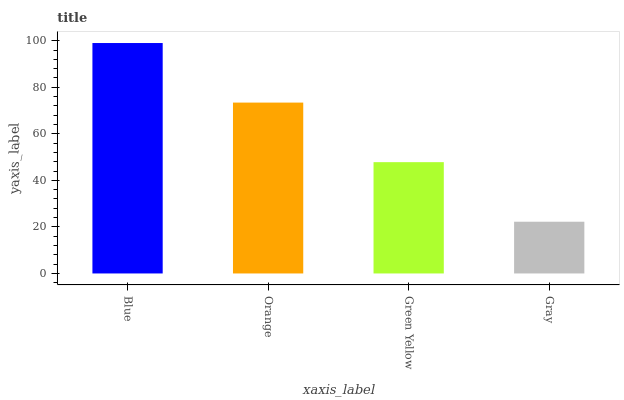Is Gray the minimum?
Answer yes or no. Yes. Is Blue the maximum?
Answer yes or no. Yes. Is Orange the minimum?
Answer yes or no. No. Is Orange the maximum?
Answer yes or no. No. Is Blue greater than Orange?
Answer yes or no. Yes. Is Orange less than Blue?
Answer yes or no. Yes. Is Orange greater than Blue?
Answer yes or no. No. Is Blue less than Orange?
Answer yes or no. No. Is Orange the high median?
Answer yes or no. Yes. Is Green Yellow the low median?
Answer yes or no. Yes. Is Green Yellow the high median?
Answer yes or no. No. Is Gray the low median?
Answer yes or no. No. 